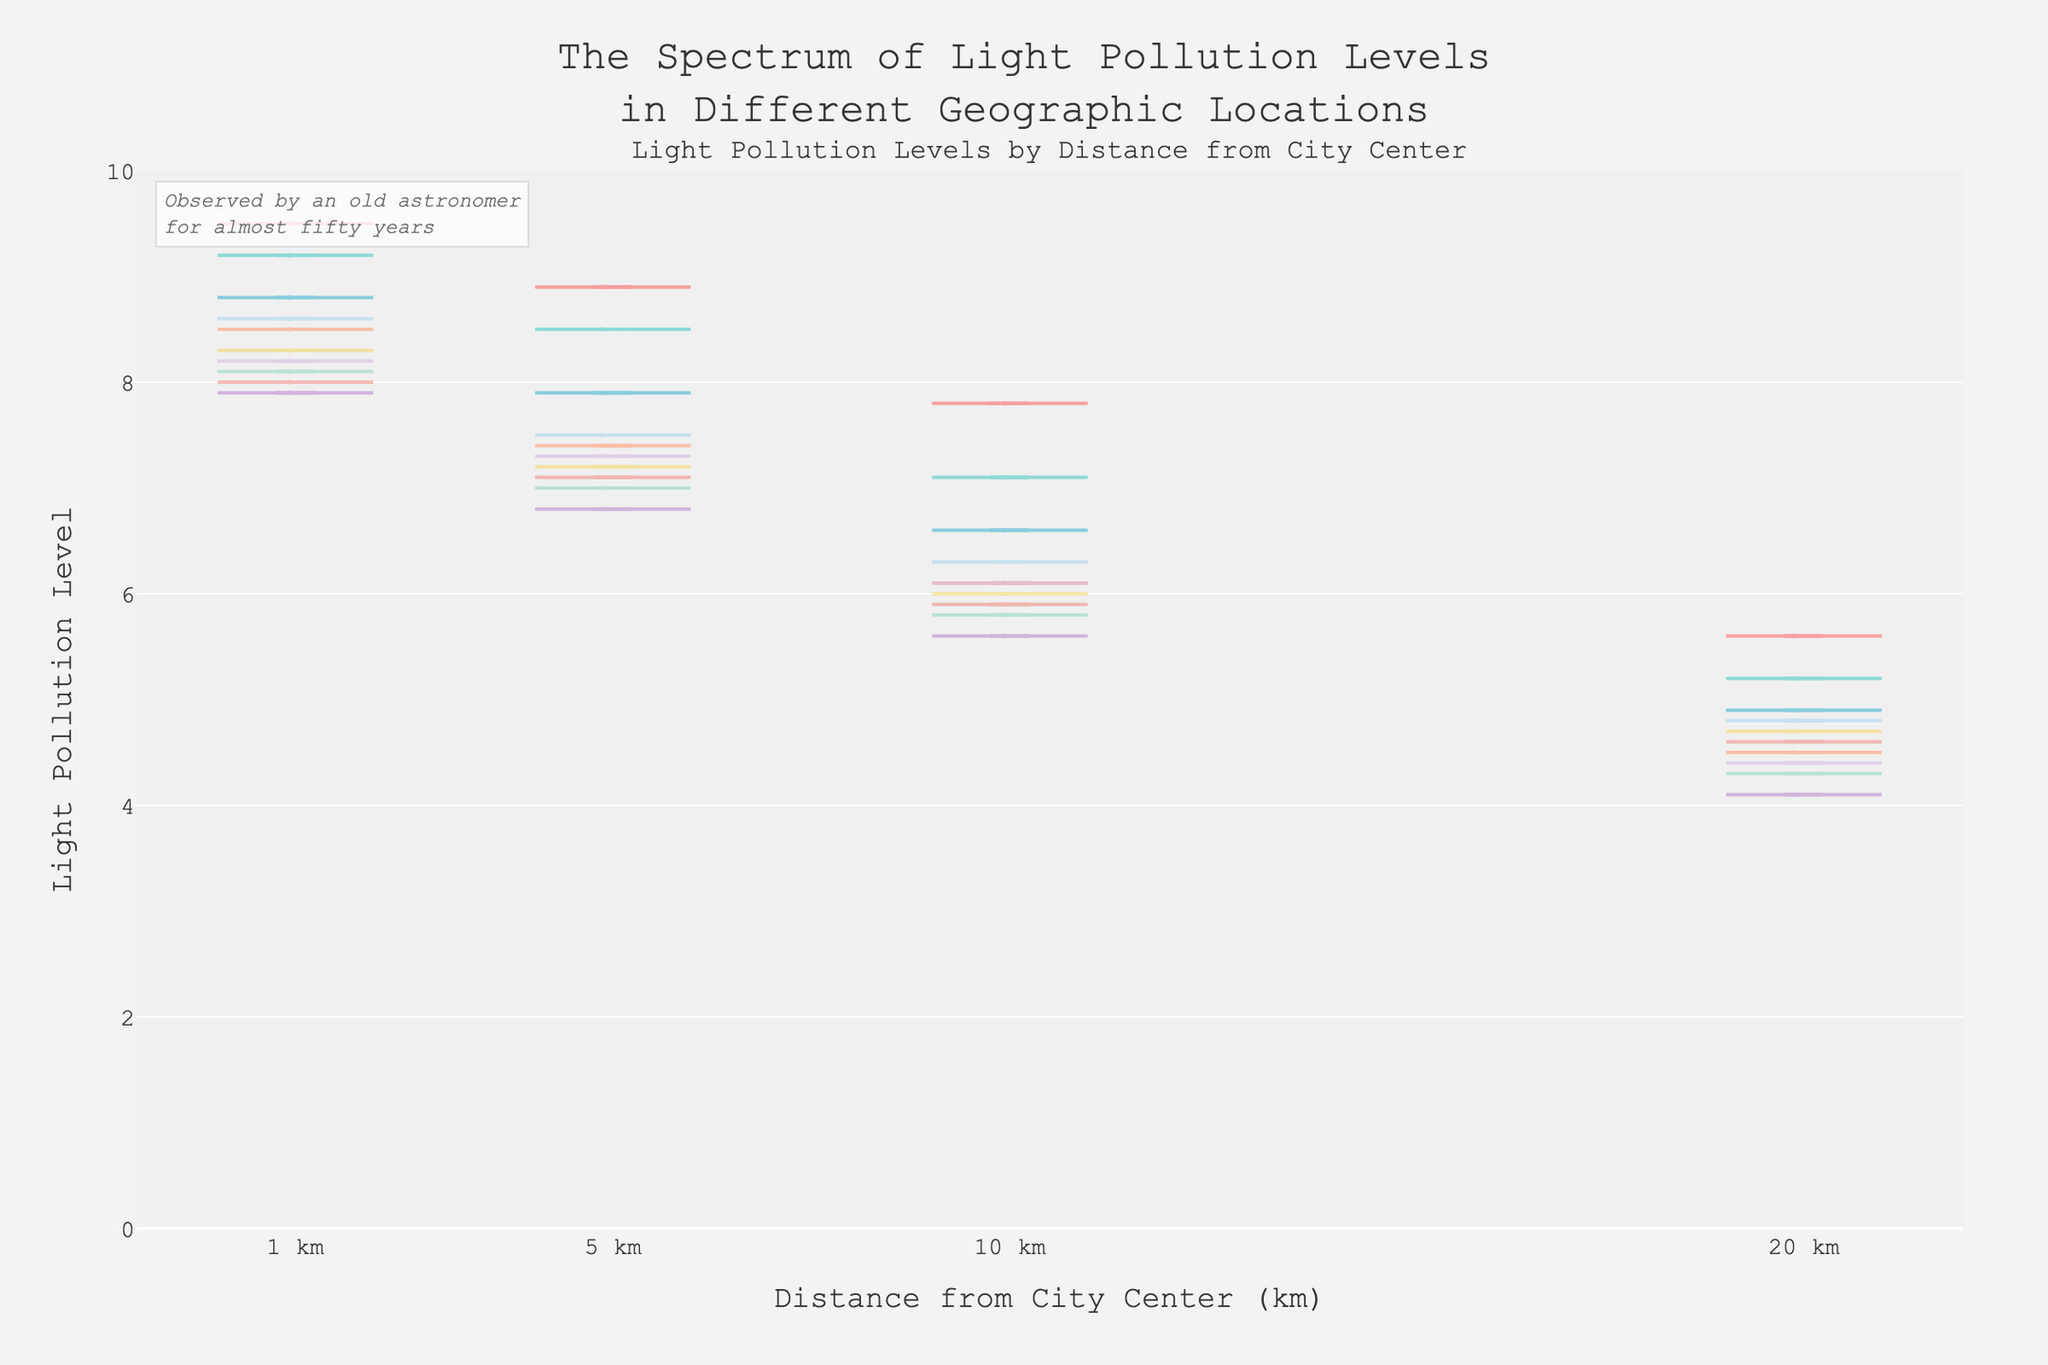1. What is the title of the figure? The title is usually prominently displayed at the top of the chart. Here, it reads: "The Spectrum of Light Pollution Levels in Different Geographic Locations".
Answer: The Spectrum of Light Pollution Levels in Different Geographic Locations 2. What do the x-axis and y-axis represent? The x-axis represents "Distance from City Center (km)" and the y-axis represents "Light Pollution Level". These labels are typically located near the respective axes.
Answer: Distance from City Center (km) and Light Pollution Level 3. Which city has the highest pollution level at 1 km from the city center? By examining the violin plots or box plots at the distance of 1 km, the highest pollution level seems to be New York City, which is indicated by a higher value on the y-axis.
Answer: New York City 4. How do the median pollution levels compare between New York City and Los Angeles at 20 km from the city center? To answer this, locate the median (indicated by the line inside the box plot) at 20 km for both cities. New York City's median is slightly higher than Los Angeles's at this distance.
Answer: New York City has a higher median 5. In which city does light pollution decrease the most when moving from 1 km to 20 km from the city center? Find the difference in pollution levels between 1 km and 20 km for each city and compare. New York City has the largest drop from 9.5 to 5.6, a decrease of 3.9 units.
Answer: New York City 6. What is the trend of pollution levels as the distance from the city center increases? Look at how the y-axis values change as you move from left to right on the x-axis across different cities. Pollution levels generally decrease as the distance from the city center increases.
Answer: Pollution levels decrease with distance 7. Are there any data points that stand out or seem unusual in the figure? Look for outliers or points that fall noticeably outside the overall trend in the violin plots. No significant outliers are visible, suggesting a consistent trend.
Answer: No significant outliers 8. Which city shows the smallest variability in pollution levels at 10 km from the city center? Variability is indicated by the width of the violin plot or the spread of the box plot. Phoenix has the smallest spread at 10 km.
Answer: Phoenix 9. How does the average pollution level change from 1 km to 10 km from the city center overall? Calculate the average pollution level at 1 km and at 10 km for all cities by summing the levels and dividing by the number of cities. There is a general decrease from high values at 1 km to lower values at 10 km. Verify the actual number: [(9.5+9.2+8.8+8.5+8.1+8.3+7.9+8.0+8.6+8.2)/10] for 1 km and [(7.8+7.1+6.6+6.1+5.8+6.0+5.6+5.9+6.3+6.1)/10] for 10 km. Average at 1 km is 8.61, and average at 10 km is 6.34, showing a decrease of 2.27.
Answer: Decreases by 2.27 10. Does any city have a pollution level below 5 at any distance from the city center? Check the y-axis values for a pollution level below 5 across all cities and distances. Houston at 20 km is 4.5, Phoenix at 20 km is 4.3, San Antonio at 20 km is 4.1, and San Jose at 20 km is 4.4.
Answer: Yes, Houston, Phoenix, San Antonio, and San Jose at 20 km 